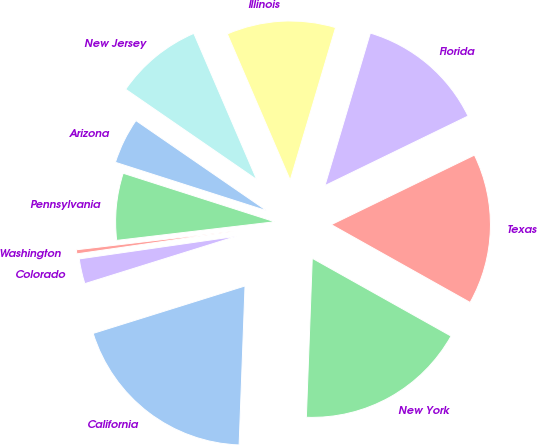Convert chart to OTSL. <chart><loc_0><loc_0><loc_500><loc_500><pie_chart><fcel>California<fcel>New York<fcel>Texas<fcel>Florida<fcel>Illinois<fcel>New Jersey<fcel>Arizona<fcel>Pennsylvania<fcel>Washington<fcel>Colorado<nl><fcel>19.59%<fcel>17.46%<fcel>15.33%<fcel>13.2%<fcel>11.07%<fcel>8.93%<fcel>4.67%<fcel>6.8%<fcel>0.41%<fcel>2.54%<nl></chart> 